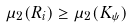Convert formula to latex. <formula><loc_0><loc_0><loc_500><loc_500>\mu _ { 2 } ( R _ { i } ) \geq \mu _ { 2 } ( K _ { \psi } )</formula> 